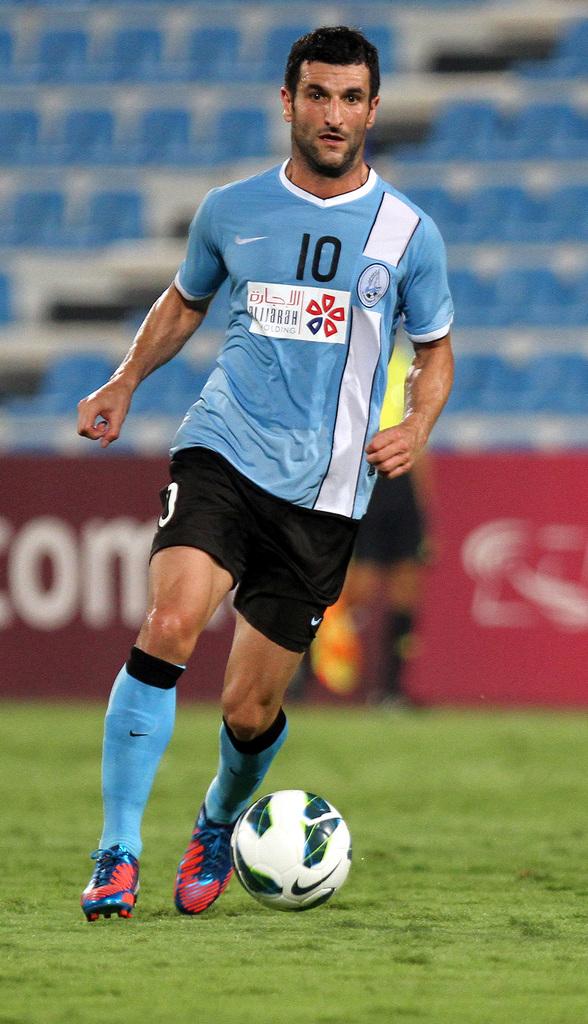What is this man's jersey number?
Make the answer very short. 10. 